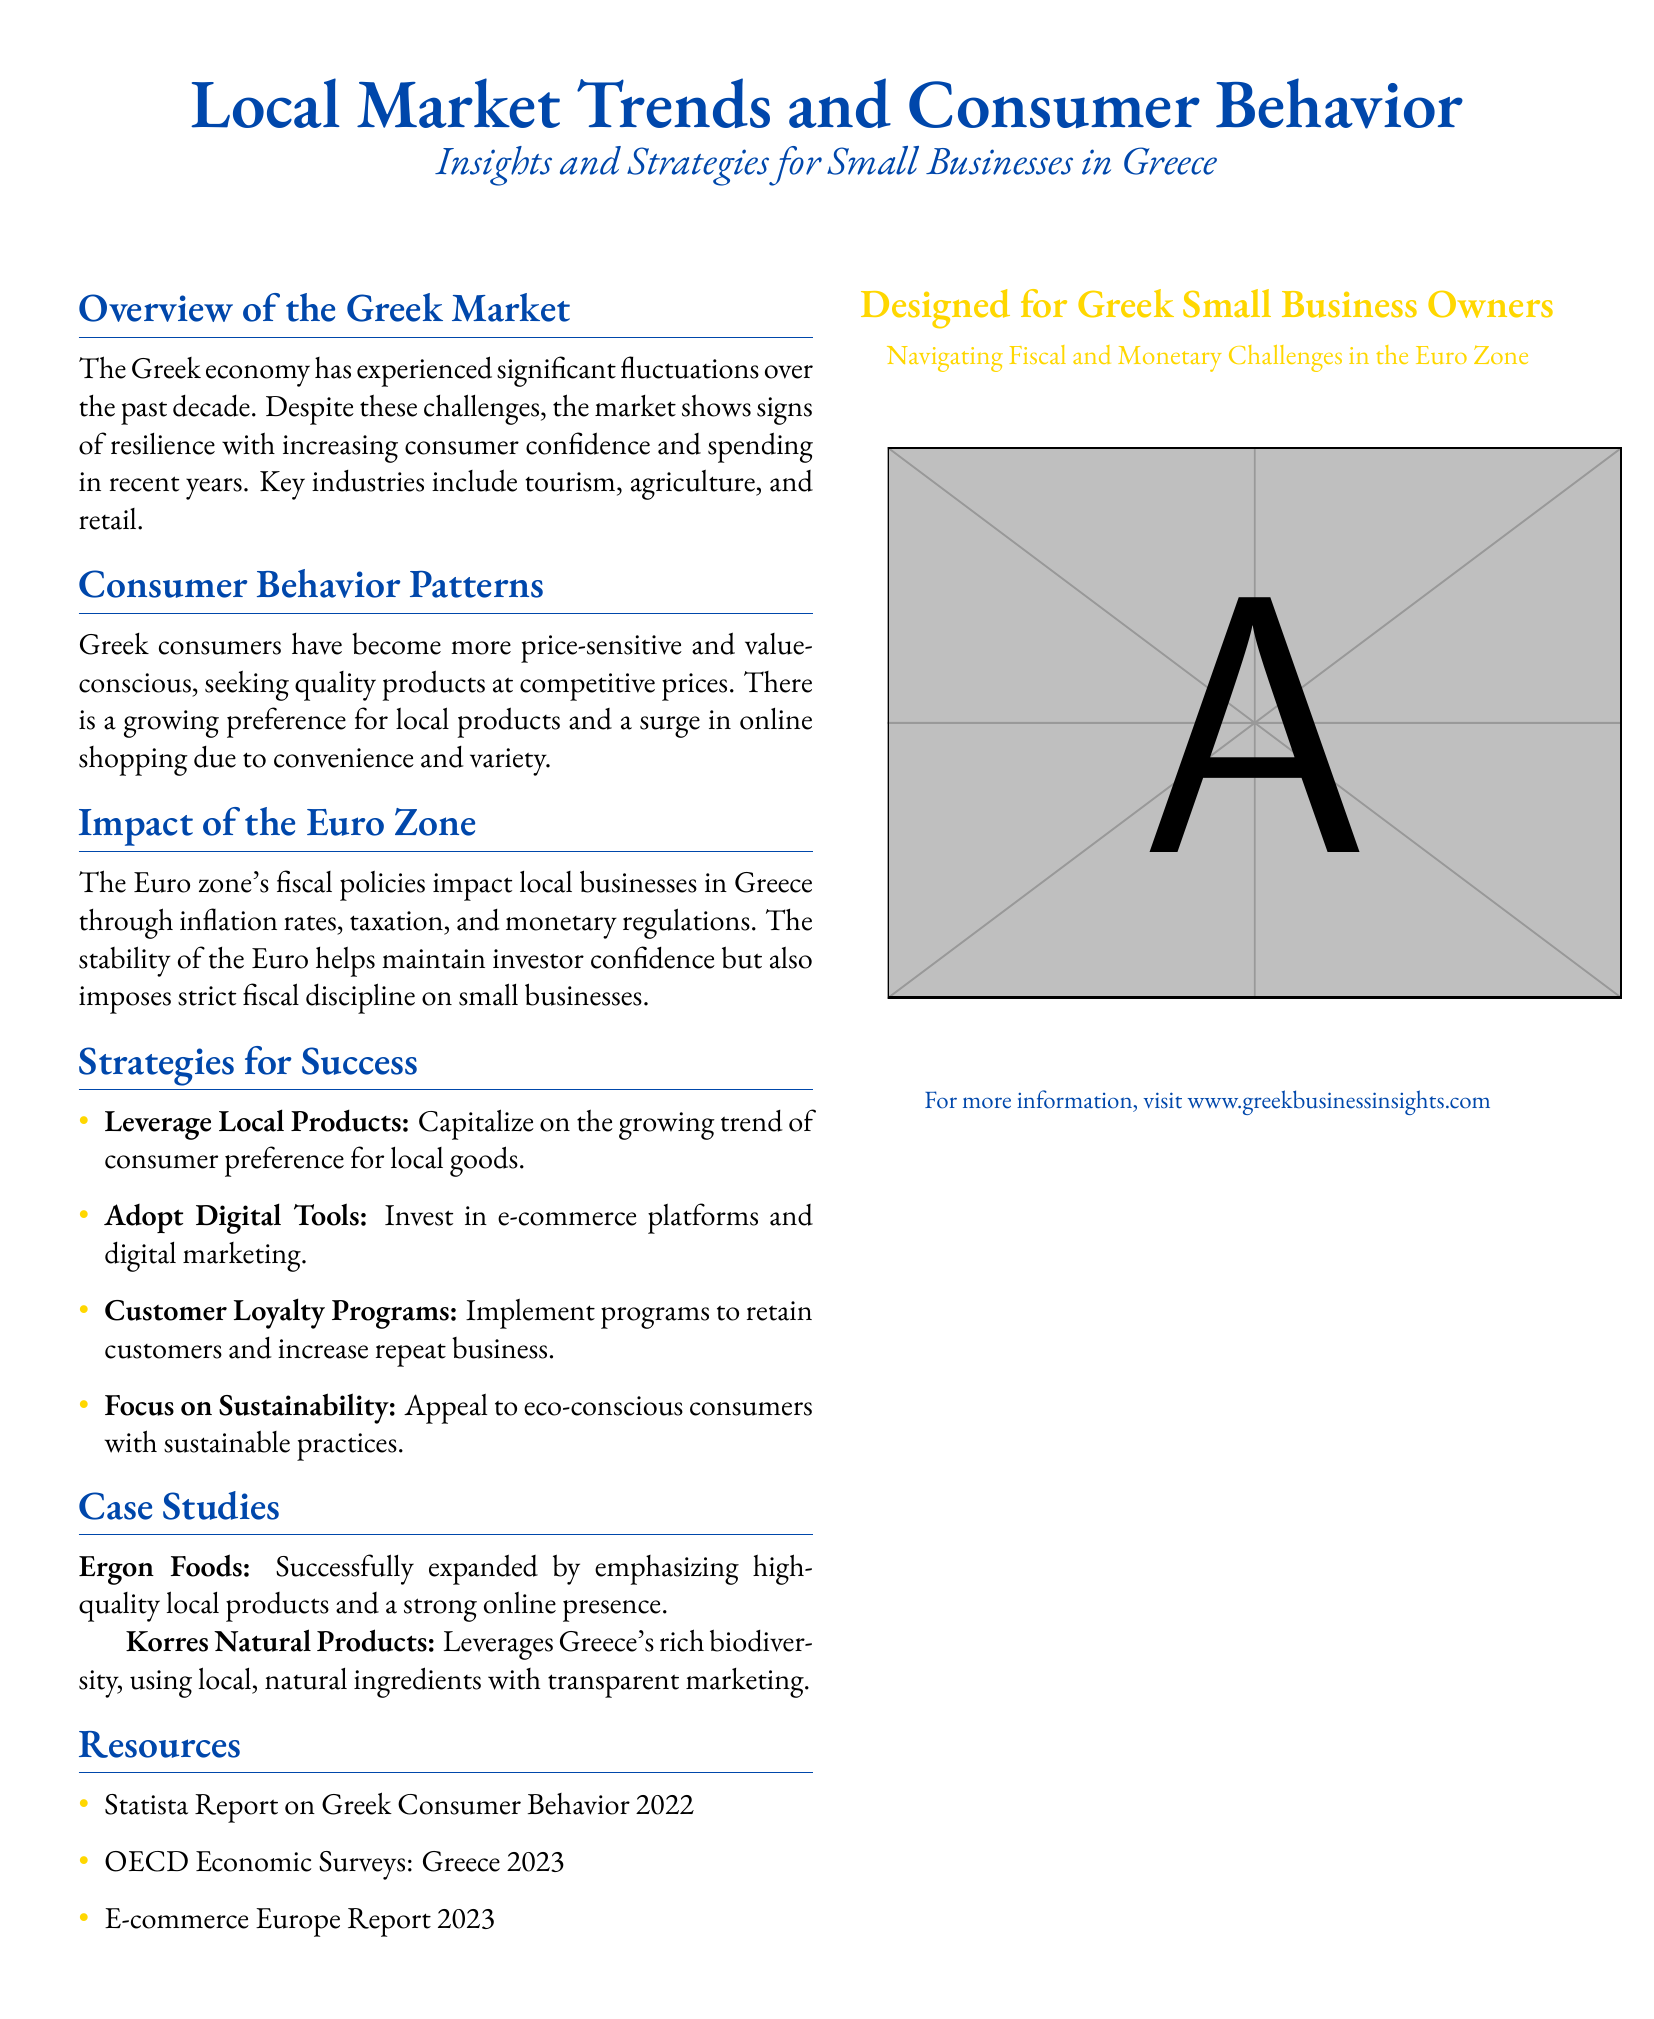What are the key industries in Greece? The document lists the primary sectors contributing to the Greek economy, which includes tourism, agriculture, and retail.
Answer: tourism, agriculture, retail What consumer trend is highlighted for Greek buyers? The document emphasizes that Greek consumers have become more price-sensitive and value-conscious.
Answer: price-sensitive and value-conscious Which company is mentioned for leveraging local products? The document provides an example of a successful business that focuses on local products, specifically naming Ergon Foods.
Answer: Ergon Foods What strategy involves retaining customers? The document lists strategies, including implementing programs designed to keep customers returning for repeat business.
Answer: Customer Loyalty Programs What year is referenced in the Statista report on consumer behavior? The document states the year of the referenced report, which focuses on Greek consumer behavior data.
Answer: 2022 What is the color associated with the title? The document indicates that the title is presented in a specific shade, which is defined as myblue.
Answer: myblue How does the Euro zone affect local businesses? The document describes the Euro zone as impacting local businesses through various means, creating strict fiscal discipline.
Answer: strict fiscal discipline What is the focus of Korres Natural Products? The document outlines the emphasis of Korres Natural Products on utilizing local ingredients, aligning with Greece's natural resources.
Answer: local, natural ingredients 